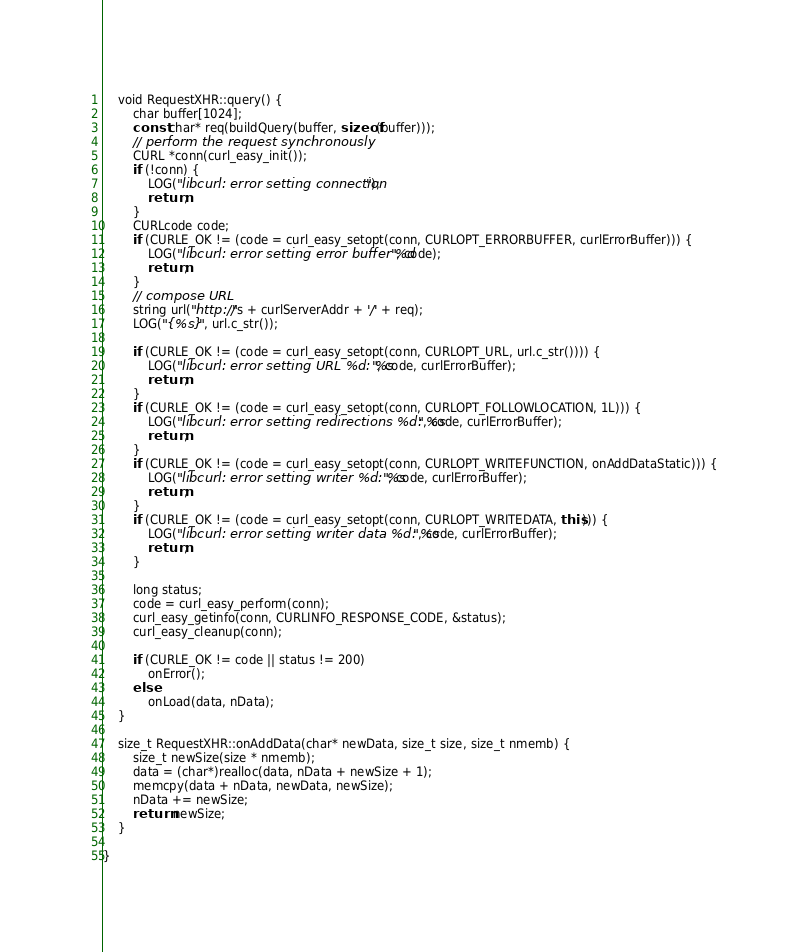<code> <loc_0><loc_0><loc_500><loc_500><_C++_>    void RequestXHR::query() {
        char buffer[1024];
        const char* req(buildQuery(buffer, sizeof(buffer)));
        // perform the request synchronously
        CURL *conn(curl_easy_init());
        if (!conn) {
            LOG("libcurl: error setting connection");
            return;
        }
        CURLcode code;
        if (CURLE_OK != (code = curl_easy_setopt(conn, CURLOPT_ERRORBUFFER, curlErrorBuffer))) {
            LOG("libcurl: error setting error buffer %d", code);
            return;
        }
        // compose URL
        string url("http://"s + curlServerAddr + '/' + req);
        LOG("{%s}", url.c_str());

        if (CURLE_OK != (code = curl_easy_setopt(conn, CURLOPT_URL, url.c_str()))) {
            LOG("libcurl: error setting URL %d: %s", code, curlErrorBuffer);
            return;
        }
        if (CURLE_OK != (code = curl_easy_setopt(conn, CURLOPT_FOLLOWLOCATION, 1L))) {
            LOG("libcurl: error setting redirections %d: %s", code, curlErrorBuffer);
            return;
        }
        if (CURLE_OK != (code = curl_easy_setopt(conn, CURLOPT_WRITEFUNCTION, onAddDataStatic))) {
            LOG("libcurl: error setting writer %d: %s", code, curlErrorBuffer);
            return;
        }
        if (CURLE_OK != (code = curl_easy_setopt(conn, CURLOPT_WRITEDATA, this))) {
            LOG("libcurl: error setting writer data %d: %s", code, curlErrorBuffer);
            return;
        }

        long status;
        code = curl_easy_perform(conn);
        curl_easy_getinfo(conn, CURLINFO_RESPONSE_CODE, &status);
        curl_easy_cleanup(conn);

        if (CURLE_OK != code || status != 200)
            onError();
        else
            onLoad(data, nData);
    }

    size_t RequestXHR::onAddData(char* newData, size_t size, size_t nmemb) {
        size_t newSize(size * nmemb);
        data = (char*)realloc(data, nData + newSize + 1);
        memcpy(data + nData, newData, newSize);
        nData += newSize;
        return newSize;
    }

}
</code> 